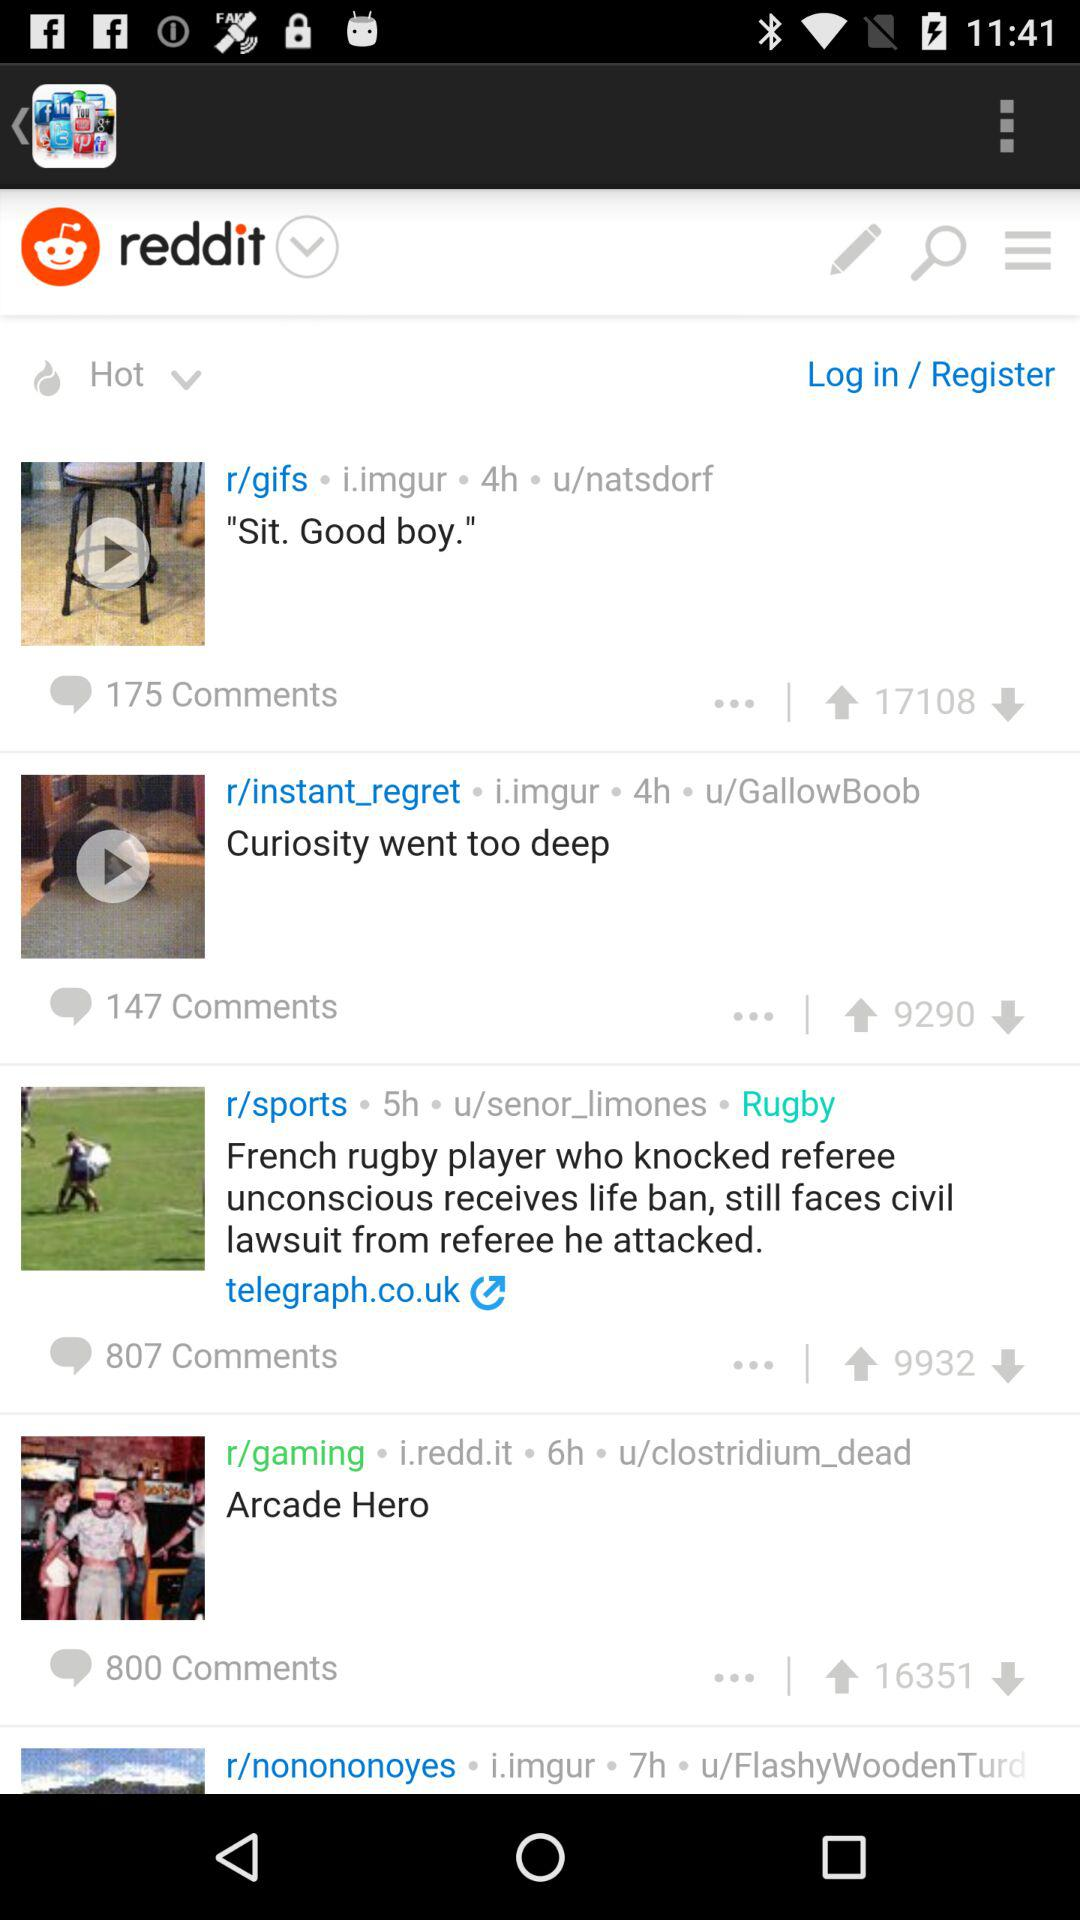What is the total number of comments for "Arcade Hero"? The total number of comments is 800. 